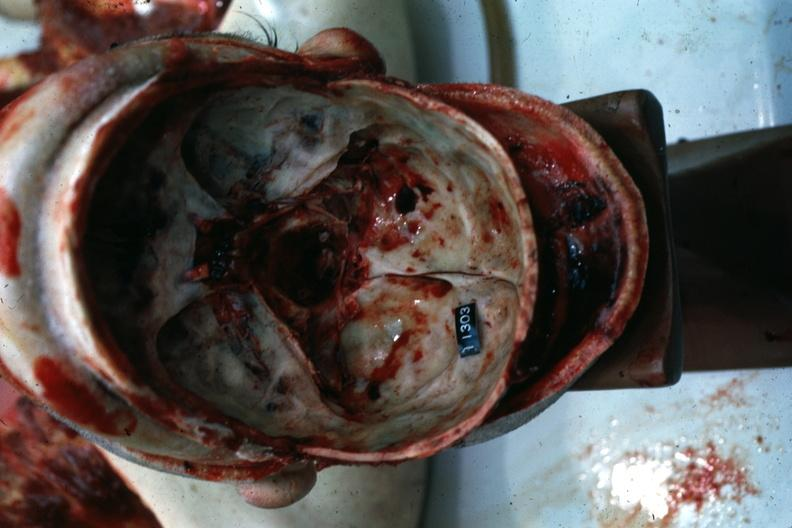s coronary atherosclerosis present?
Answer the question using a single word or phrase. No 